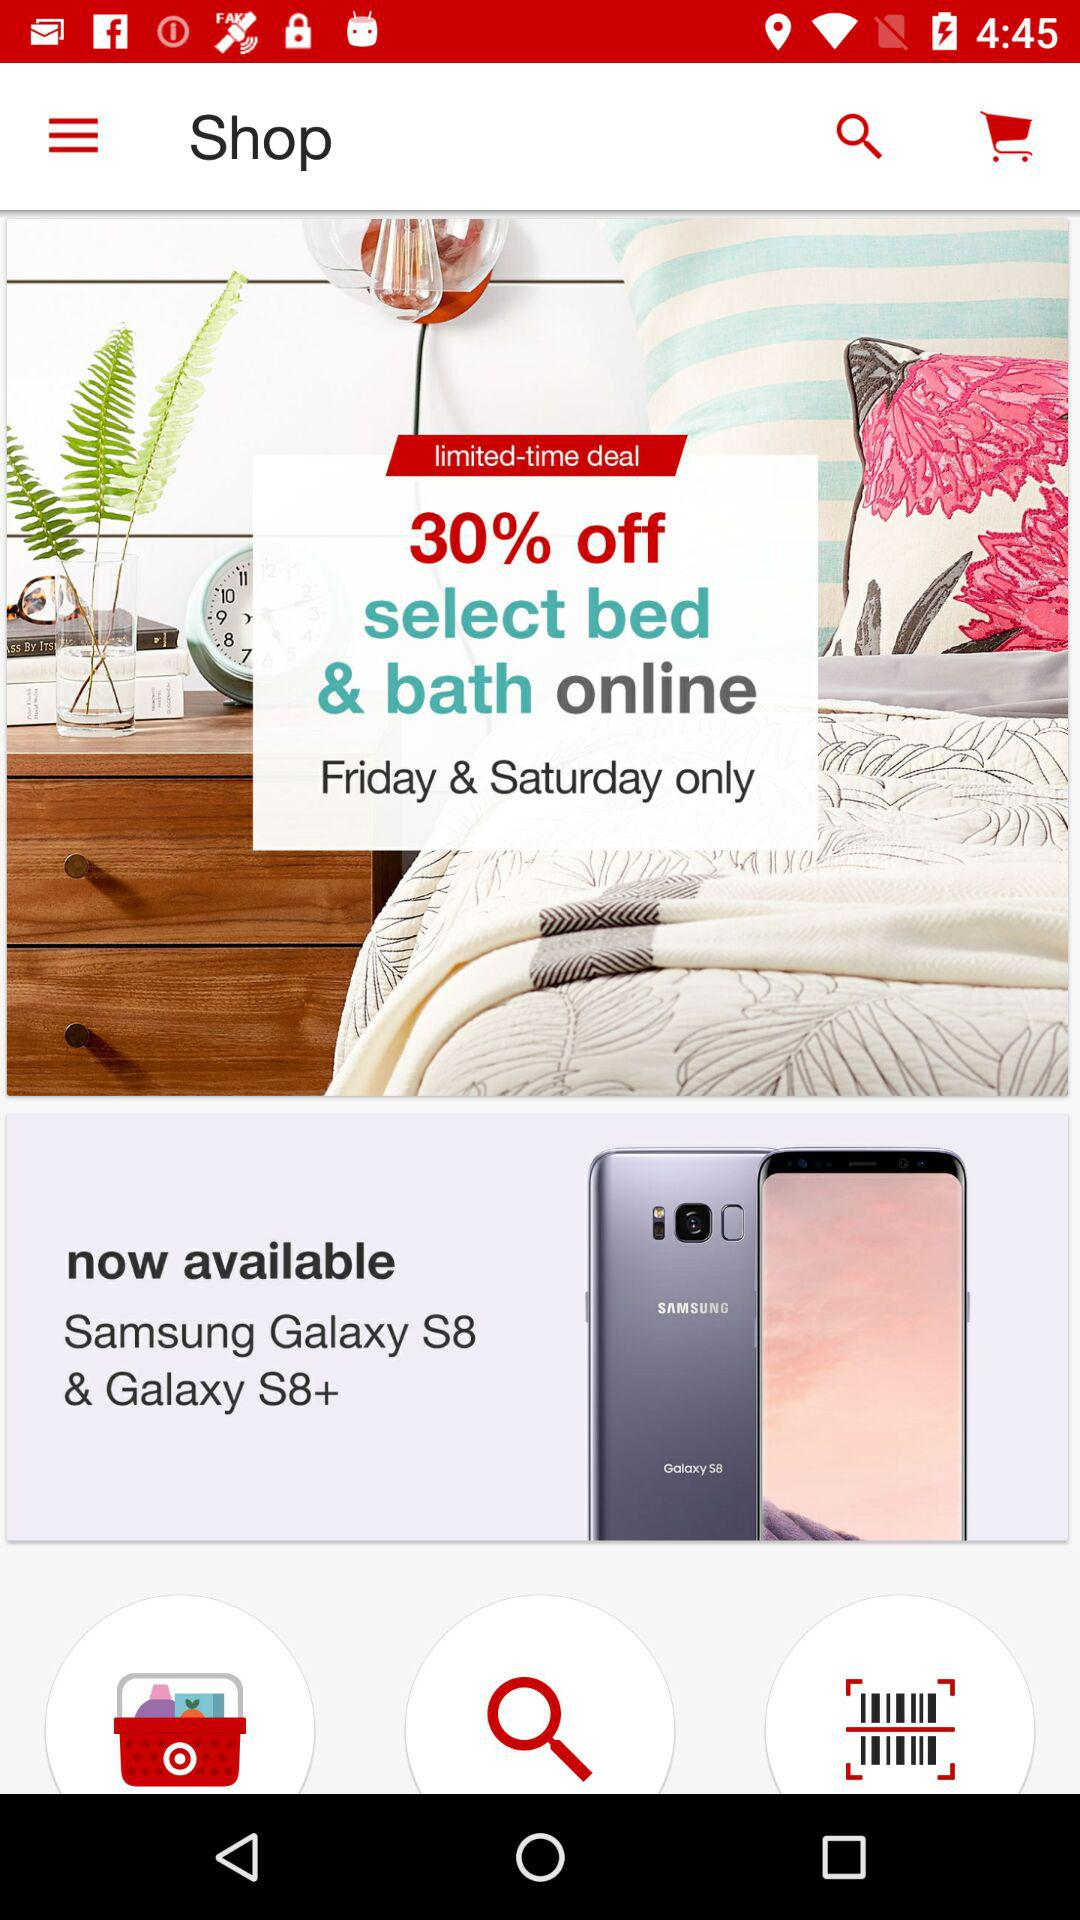How much discount is available on an online purchase of bed and bath products? The available discount is 30%. 